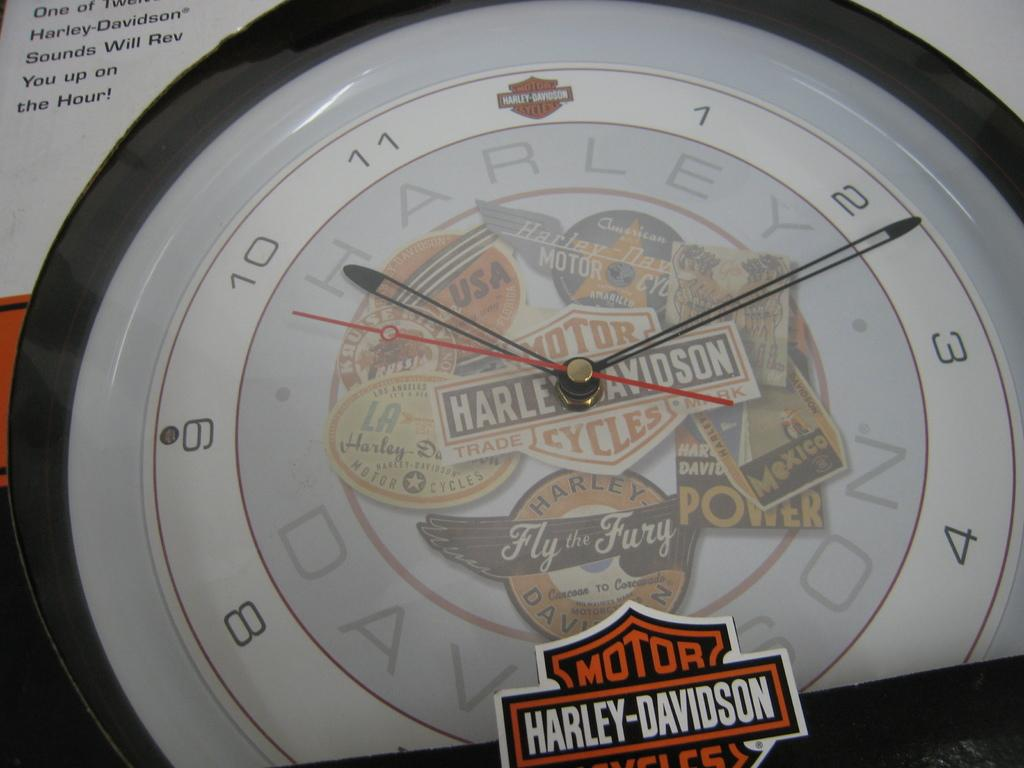Provide a one-sentence caption for the provided image. A clock made by Harley Davidson motorcycles  that says fly the fury. 